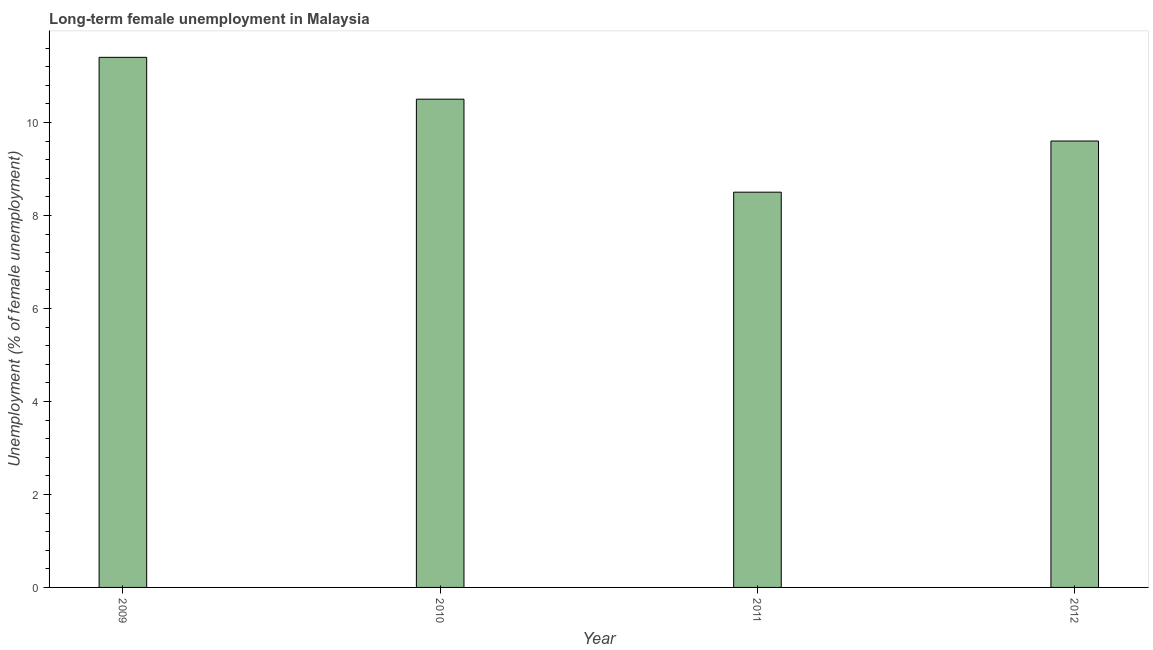What is the title of the graph?
Provide a short and direct response. Long-term female unemployment in Malaysia. What is the label or title of the Y-axis?
Offer a terse response. Unemployment (% of female unemployment). What is the long-term female unemployment in 2009?
Provide a short and direct response. 11.4. Across all years, what is the maximum long-term female unemployment?
Your answer should be very brief. 11.4. What is the sum of the long-term female unemployment?
Provide a short and direct response. 40. What is the median long-term female unemployment?
Offer a terse response. 10.05. In how many years, is the long-term female unemployment greater than 9.2 %?
Offer a very short reply. 3. Do a majority of the years between 2011 and 2012 (inclusive) have long-term female unemployment greater than 0.4 %?
Ensure brevity in your answer.  Yes. What is the ratio of the long-term female unemployment in 2010 to that in 2012?
Offer a very short reply. 1.09. Is the sum of the long-term female unemployment in 2009 and 2011 greater than the maximum long-term female unemployment across all years?
Offer a very short reply. Yes. What is the difference between the highest and the lowest long-term female unemployment?
Your answer should be very brief. 2.9. Are all the bars in the graph horizontal?
Offer a terse response. No. What is the Unemployment (% of female unemployment) of 2009?
Provide a succinct answer. 11.4. What is the Unemployment (% of female unemployment) in 2010?
Offer a very short reply. 10.5. What is the Unemployment (% of female unemployment) in 2012?
Keep it short and to the point. 9.6. What is the difference between the Unemployment (% of female unemployment) in 2009 and 2010?
Ensure brevity in your answer.  0.9. What is the difference between the Unemployment (% of female unemployment) in 2009 and 2012?
Provide a succinct answer. 1.8. What is the difference between the Unemployment (% of female unemployment) in 2010 and 2011?
Offer a terse response. 2. What is the ratio of the Unemployment (% of female unemployment) in 2009 to that in 2010?
Give a very brief answer. 1.09. What is the ratio of the Unemployment (% of female unemployment) in 2009 to that in 2011?
Keep it short and to the point. 1.34. What is the ratio of the Unemployment (% of female unemployment) in 2009 to that in 2012?
Give a very brief answer. 1.19. What is the ratio of the Unemployment (% of female unemployment) in 2010 to that in 2011?
Your answer should be compact. 1.24. What is the ratio of the Unemployment (% of female unemployment) in 2010 to that in 2012?
Provide a short and direct response. 1.09. What is the ratio of the Unemployment (% of female unemployment) in 2011 to that in 2012?
Offer a very short reply. 0.89. 